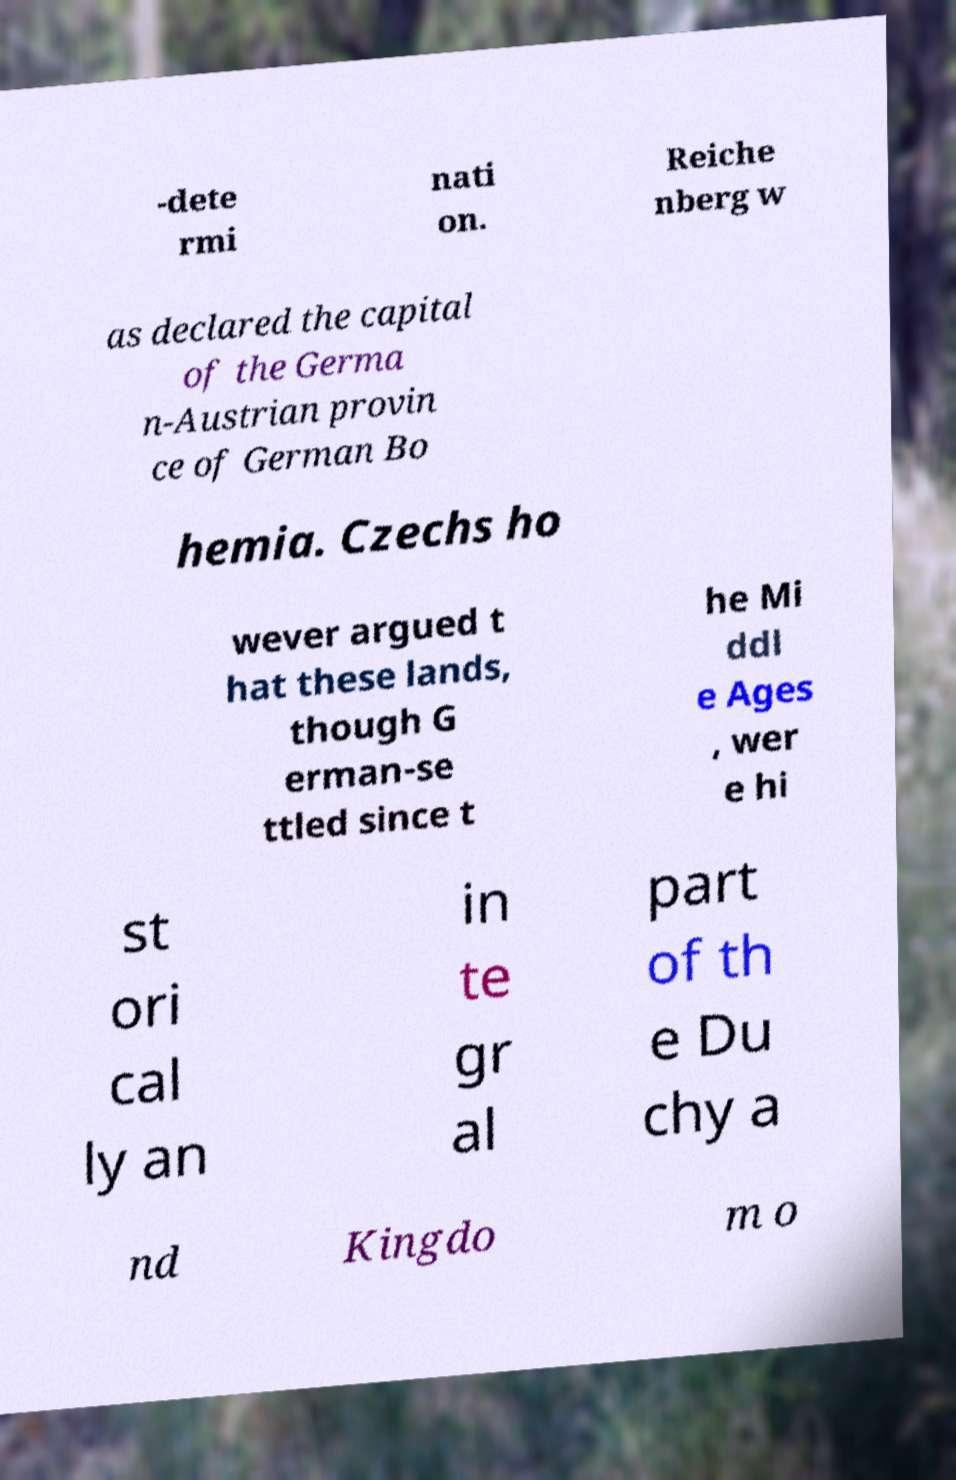I need the written content from this picture converted into text. Can you do that? -dete rmi nati on. Reiche nberg w as declared the capital of the Germa n-Austrian provin ce of German Bo hemia. Czechs ho wever argued t hat these lands, though G erman-se ttled since t he Mi ddl e Ages , wer e hi st ori cal ly an in te gr al part of th e Du chy a nd Kingdo m o 